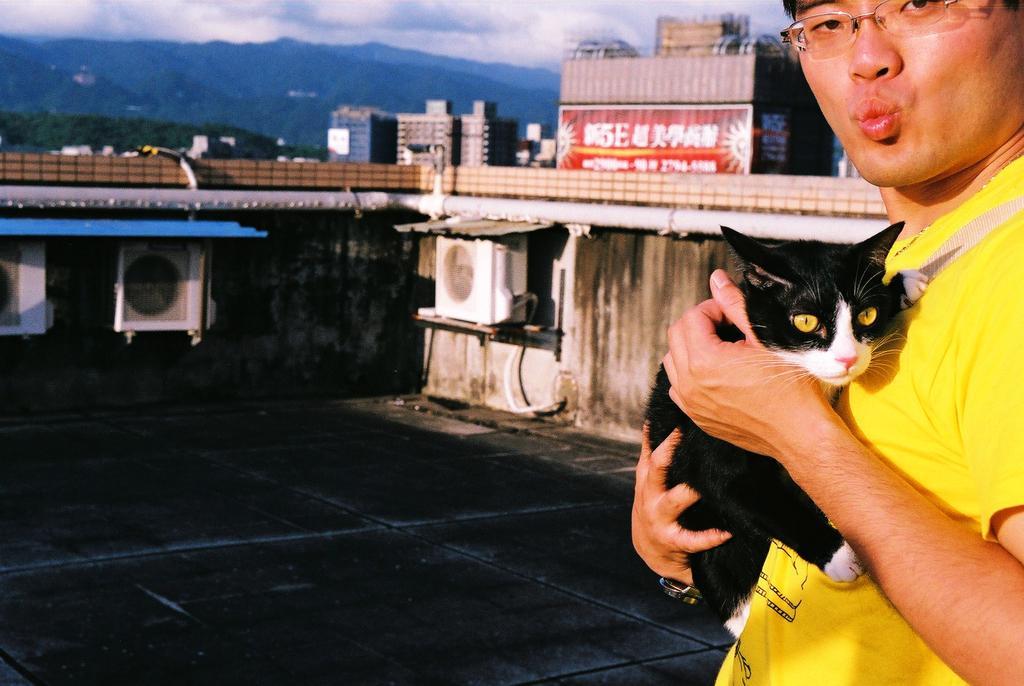Describe this image in one or two sentences. In this picture there is a man standing on to the left and there is a cat in his hand. In the backdrop there is a wall, a building, mountain and sky is cloudy. 